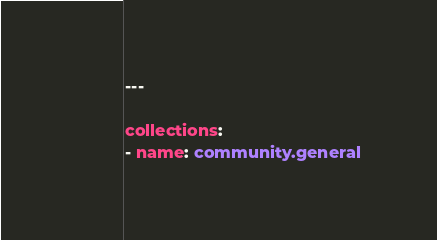<code> <loc_0><loc_0><loc_500><loc_500><_YAML_>---

collections:
- name: community.general
</code> 